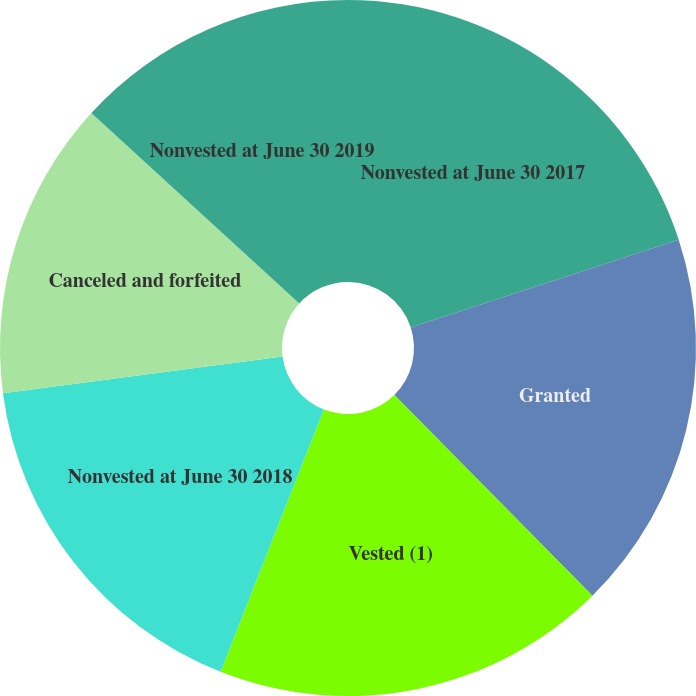Convert chart to OTSL. <chart><loc_0><loc_0><loc_500><loc_500><pie_chart><fcel>Nonvested at June 30 2017<fcel>Granted<fcel>Vested (1)<fcel>Nonvested at June 30 2018<fcel>Canceled and forfeited<fcel>Nonvested at June 30 2019<nl><fcel>19.96%<fcel>17.64%<fcel>18.36%<fcel>16.96%<fcel>13.87%<fcel>13.2%<nl></chart> 